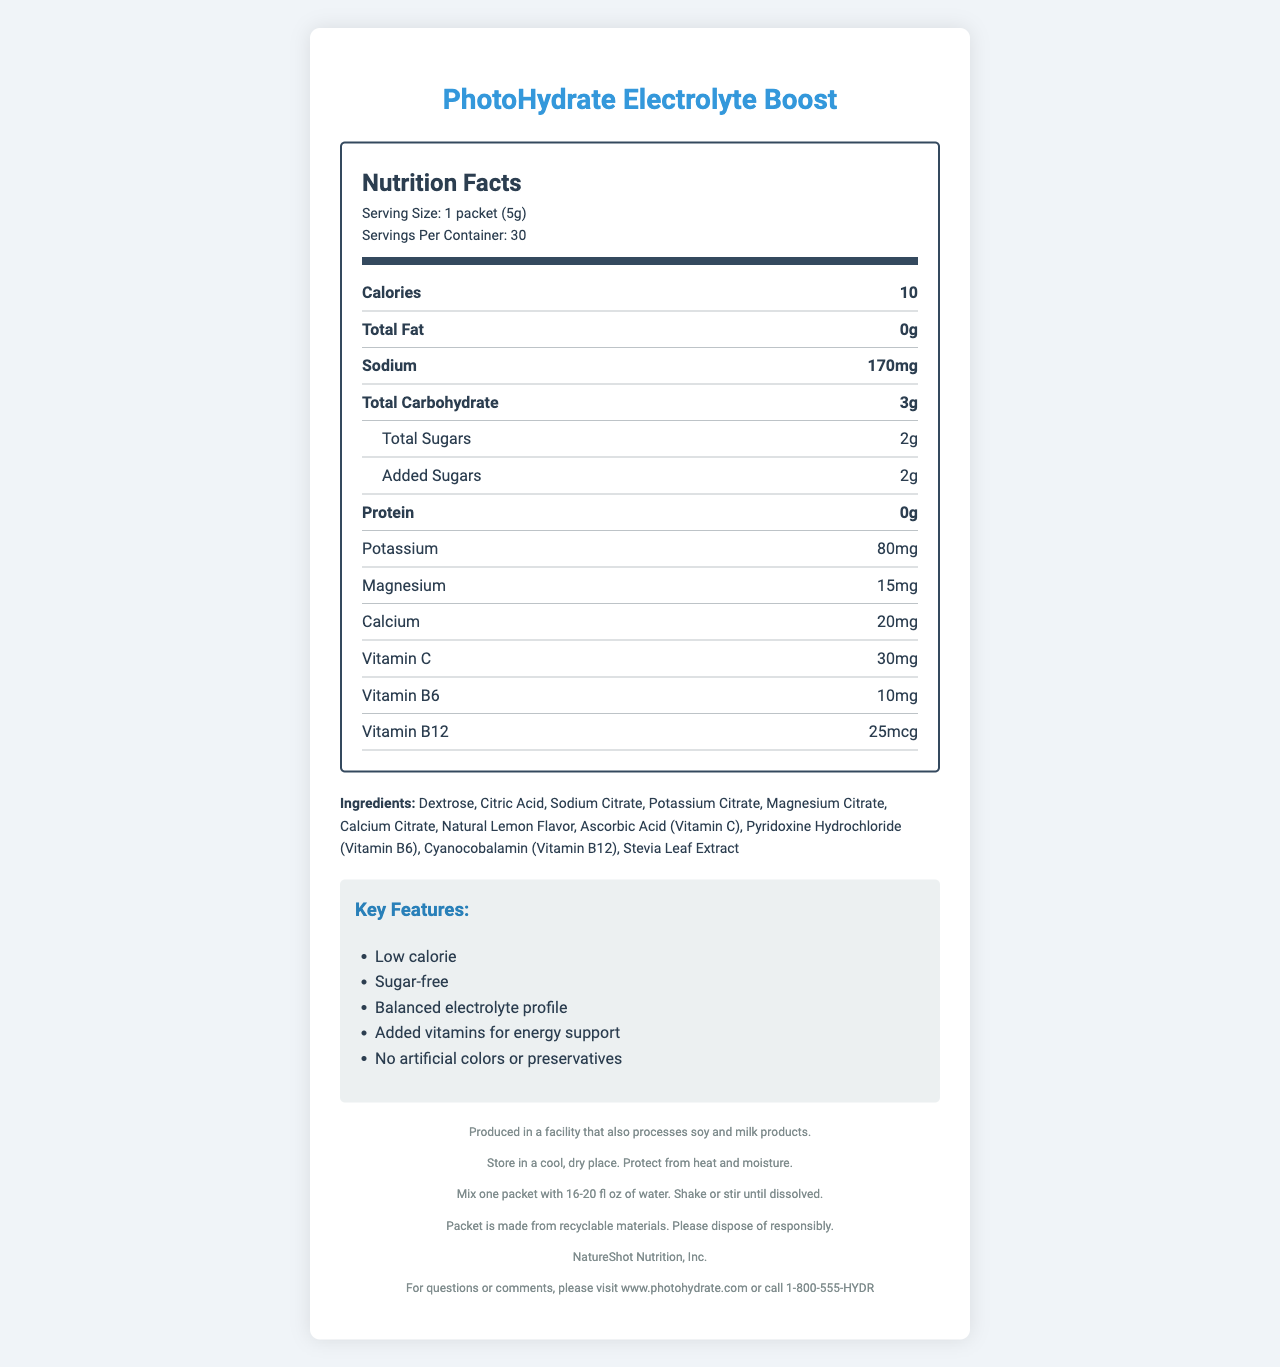what is the serving size of the PhotoHydrate Electrolyte Boost? The serving size is clearly listed as "1 packet (5g)" in the document.
Answer: 1 packet (5g) how many calories are in one serving of this product? The document specifies that there are 10 calories per serving.
Answer: 10 how many packets are included in one container? The document mentions that there are 30 servings per container, which equals 30 packets.
Answer: 30 what is the total amount of sugar in one serving (in grams)? The document lists "Total Sugars" as 2 grams.
Answer: 2 grams is this product sugar-free? It contains 2 grams of total sugars and 2 grams of added sugars per serving, so it is not sugar-free.
Answer: No how much sodium does one serving contain? The sodium content per serving is listed as 170 mg.
Answer: 170 mg which of the following vitamins are included in this product? A. Vitamin D B. Vitamin C C. Vitamin B6 D. Vitamin B12 The document lists Vitamin C, Vitamin B6, and Vitamin B12 as ingredients but does not mention Vitamin D.
Answer: B, C, D what is one key feature of this product related to electrolytes? The document lists "Balanced electrolyte profile" as a key feature.
Answer: Balanced electrolyte profile are there any allergens present in this product? The allergen information indicates that it is produced in a facility that also processes soy and milk products.
Answer: Produced in a facility that also processes soy and milk products where should this product be stored? The storage instructions are provided in the document.
Answer: Store in a cool, dry place. Protect from heat and moisture. summarize the main features of PhotoHydrate Electrolyte Boost The document provides detailed information on the nutritional content, ingredients, key features, allergen info, storage instructions, and environmental information, painting a comprehensive picture of the product's benefits and usage.
Answer: PhotoHydrate Electrolyte Boost is a low-calorie, electrolyte-enhanced water flavoring packet designed for optimal hydration during extended outdoor photography sessions. Each packet contains 10 calories, essential electrolytes like sodium, potassium, and magnesium, as well as added vitamins C, B6, and B12. It is sugar-free, has no artificial colors or preservatives, and comes with clear storage and usage instructions. The packaging is recyclable. can we use this product for an indoor photography session? The document specifically states that the intended use is for outdoor photography sessions, but it does not provide information about indoor use.
Answer: Not enough information how much protein is in one serving? The document states that the protein content per serving is 0 grams.
Answer: 0 grams is the packet recyclable? The document states that the packet is made from recyclable materials.
Answer: Yes which company manufactures this product? 1. NatureShot Nutrition, Inc. 2. Electrolyte Factory 3. Hydration Co. The document mentions that NatureShot Nutrition, Inc. is the manufacturer.
Answer: 1 should the product be protected from heat and moisture during storage? The document states, "Store in a cool, dry place. Protect from heat and moisture."
Answer: Yes how should one use the PhotoHydrate Electrolyte Boost packet? The directions clearly describe mixing one packet with 16-20 fl oz of water and shaking or stirring until dissolved.
Answer: Mix one packet with 16-20 fl oz of water. Shake or stir until dissolved. what is the primary purpose of this product? The document specifies this intended use explicitly.
Answer: For optimal hydration during extended outdoor photography sessions who should be contacted for questions or comments about the product? The contact information includes a website and a phone number for inquiries.
Answer: Visit www.photohydrate.com or call 1-800-555-HYDR 